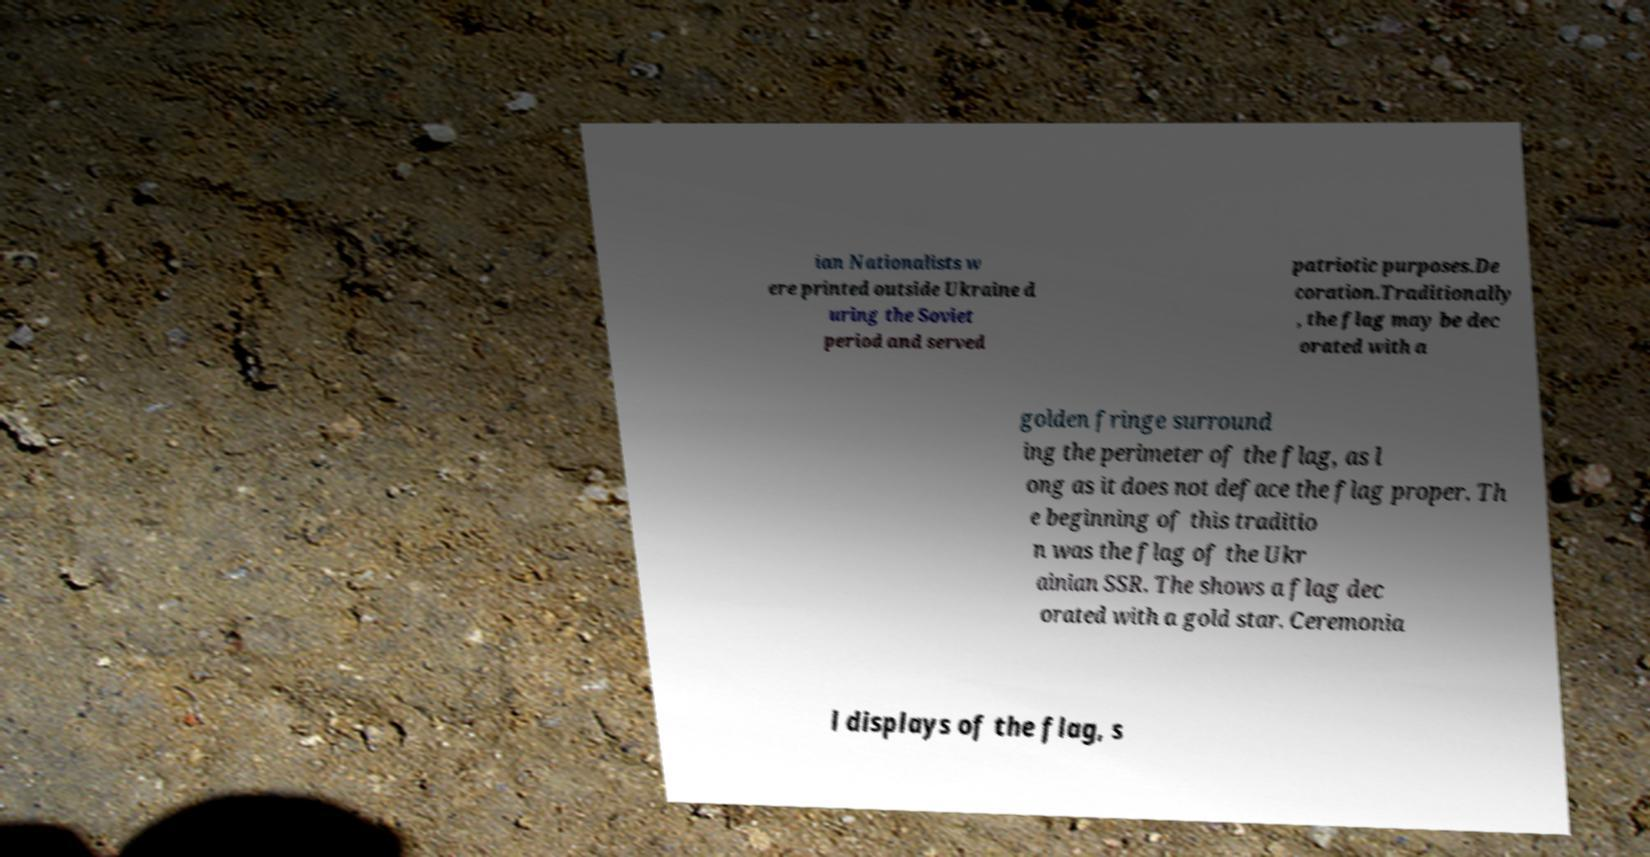Can you read and provide the text displayed in the image?This photo seems to have some interesting text. Can you extract and type it out for me? ian Nationalists w ere printed outside Ukraine d uring the Soviet period and served patriotic purposes.De coration.Traditionally , the flag may be dec orated with a golden fringe surround ing the perimeter of the flag, as l ong as it does not deface the flag proper. Th e beginning of this traditio n was the flag of the Ukr ainian SSR. The shows a flag dec orated with a gold star. Ceremonia l displays of the flag, s 